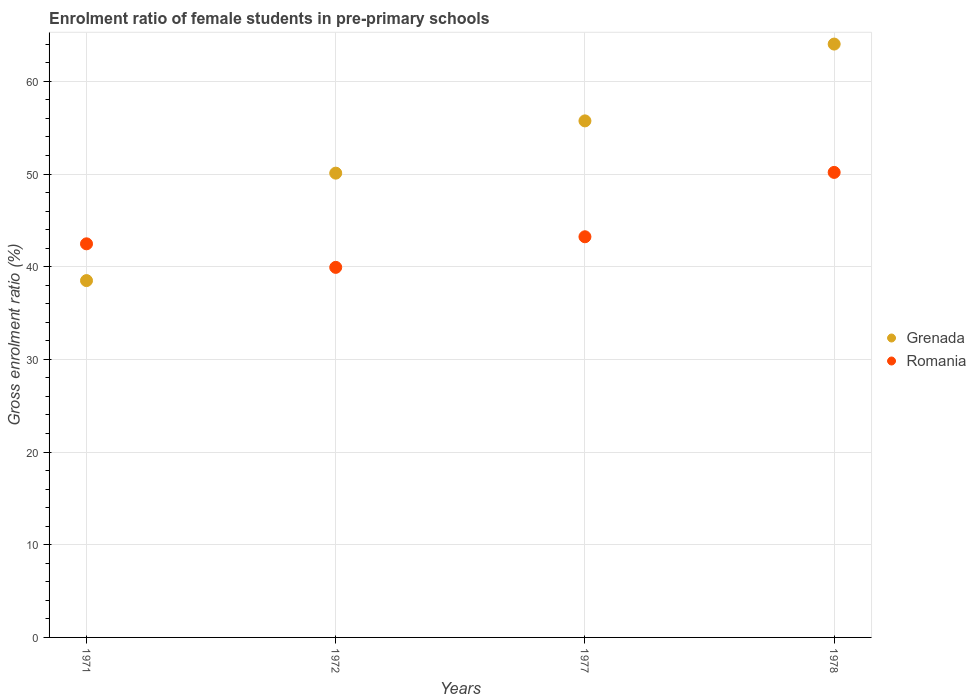Is the number of dotlines equal to the number of legend labels?
Provide a short and direct response. Yes. What is the enrolment ratio of female students in pre-primary schools in Romania in 1971?
Provide a succinct answer. 42.47. Across all years, what is the maximum enrolment ratio of female students in pre-primary schools in Romania?
Make the answer very short. 50.17. Across all years, what is the minimum enrolment ratio of female students in pre-primary schools in Romania?
Offer a very short reply. 39.93. In which year was the enrolment ratio of female students in pre-primary schools in Romania maximum?
Ensure brevity in your answer.  1978. What is the total enrolment ratio of female students in pre-primary schools in Grenada in the graph?
Offer a terse response. 208.35. What is the difference between the enrolment ratio of female students in pre-primary schools in Romania in 1972 and that in 1977?
Offer a very short reply. -3.3. What is the difference between the enrolment ratio of female students in pre-primary schools in Grenada in 1972 and the enrolment ratio of female students in pre-primary schools in Romania in 1977?
Make the answer very short. 6.86. What is the average enrolment ratio of female students in pre-primary schools in Romania per year?
Offer a terse response. 43.95. In the year 1978, what is the difference between the enrolment ratio of female students in pre-primary schools in Romania and enrolment ratio of female students in pre-primary schools in Grenada?
Provide a succinct answer. -13.85. What is the ratio of the enrolment ratio of female students in pre-primary schools in Romania in 1972 to that in 1977?
Ensure brevity in your answer.  0.92. Is the enrolment ratio of female students in pre-primary schools in Romania in 1971 less than that in 1972?
Provide a short and direct response. No. What is the difference between the highest and the second highest enrolment ratio of female students in pre-primary schools in Romania?
Give a very brief answer. 6.94. What is the difference between the highest and the lowest enrolment ratio of female students in pre-primary schools in Romania?
Provide a succinct answer. 10.25. How many years are there in the graph?
Offer a terse response. 4. Are the values on the major ticks of Y-axis written in scientific E-notation?
Offer a terse response. No. Does the graph contain grids?
Make the answer very short. Yes. How many legend labels are there?
Make the answer very short. 2. What is the title of the graph?
Offer a very short reply. Enrolment ratio of female students in pre-primary schools. Does "Colombia" appear as one of the legend labels in the graph?
Give a very brief answer. No. What is the Gross enrolment ratio (%) of Grenada in 1971?
Your response must be concise. 38.5. What is the Gross enrolment ratio (%) in Romania in 1971?
Give a very brief answer. 42.47. What is the Gross enrolment ratio (%) in Grenada in 1972?
Make the answer very short. 50.09. What is the Gross enrolment ratio (%) in Romania in 1972?
Give a very brief answer. 39.93. What is the Gross enrolment ratio (%) in Grenada in 1977?
Provide a short and direct response. 55.73. What is the Gross enrolment ratio (%) in Romania in 1977?
Provide a short and direct response. 43.23. What is the Gross enrolment ratio (%) of Grenada in 1978?
Your answer should be very brief. 64.02. What is the Gross enrolment ratio (%) of Romania in 1978?
Your response must be concise. 50.17. Across all years, what is the maximum Gross enrolment ratio (%) of Grenada?
Make the answer very short. 64.02. Across all years, what is the maximum Gross enrolment ratio (%) in Romania?
Offer a terse response. 50.17. Across all years, what is the minimum Gross enrolment ratio (%) in Grenada?
Provide a succinct answer. 38.5. Across all years, what is the minimum Gross enrolment ratio (%) in Romania?
Your answer should be compact. 39.93. What is the total Gross enrolment ratio (%) of Grenada in the graph?
Provide a succinct answer. 208.35. What is the total Gross enrolment ratio (%) in Romania in the graph?
Provide a short and direct response. 175.8. What is the difference between the Gross enrolment ratio (%) in Grenada in 1971 and that in 1972?
Provide a succinct answer. -11.59. What is the difference between the Gross enrolment ratio (%) of Romania in 1971 and that in 1972?
Offer a very short reply. 2.54. What is the difference between the Gross enrolment ratio (%) of Grenada in 1971 and that in 1977?
Provide a short and direct response. -17.23. What is the difference between the Gross enrolment ratio (%) in Romania in 1971 and that in 1977?
Provide a short and direct response. -0.76. What is the difference between the Gross enrolment ratio (%) in Grenada in 1971 and that in 1978?
Your answer should be very brief. -25.52. What is the difference between the Gross enrolment ratio (%) of Romania in 1971 and that in 1978?
Provide a short and direct response. -7.71. What is the difference between the Gross enrolment ratio (%) in Grenada in 1972 and that in 1977?
Your answer should be compact. -5.64. What is the difference between the Gross enrolment ratio (%) of Romania in 1972 and that in 1977?
Your answer should be compact. -3.3. What is the difference between the Gross enrolment ratio (%) in Grenada in 1972 and that in 1978?
Offer a very short reply. -13.93. What is the difference between the Gross enrolment ratio (%) of Romania in 1972 and that in 1978?
Your answer should be compact. -10.25. What is the difference between the Gross enrolment ratio (%) in Grenada in 1977 and that in 1978?
Provide a short and direct response. -8.29. What is the difference between the Gross enrolment ratio (%) in Romania in 1977 and that in 1978?
Make the answer very short. -6.94. What is the difference between the Gross enrolment ratio (%) of Grenada in 1971 and the Gross enrolment ratio (%) of Romania in 1972?
Offer a terse response. -1.43. What is the difference between the Gross enrolment ratio (%) in Grenada in 1971 and the Gross enrolment ratio (%) in Romania in 1977?
Your answer should be compact. -4.73. What is the difference between the Gross enrolment ratio (%) of Grenada in 1971 and the Gross enrolment ratio (%) of Romania in 1978?
Your response must be concise. -11.67. What is the difference between the Gross enrolment ratio (%) of Grenada in 1972 and the Gross enrolment ratio (%) of Romania in 1977?
Provide a short and direct response. 6.86. What is the difference between the Gross enrolment ratio (%) of Grenada in 1972 and the Gross enrolment ratio (%) of Romania in 1978?
Make the answer very short. -0.08. What is the difference between the Gross enrolment ratio (%) in Grenada in 1977 and the Gross enrolment ratio (%) in Romania in 1978?
Your answer should be compact. 5.56. What is the average Gross enrolment ratio (%) in Grenada per year?
Make the answer very short. 52.09. What is the average Gross enrolment ratio (%) of Romania per year?
Keep it short and to the point. 43.95. In the year 1971, what is the difference between the Gross enrolment ratio (%) in Grenada and Gross enrolment ratio (%) in Romania?
Provide a succinct answer. -3.97. In the year 1972, what is the difference between the Gross enrolment ratio (%) of Grenada and Gross enrolment ratio (%) of Romania?
Your answer should be compact. 10.17. In the year 1977, what is the difference between the Gross enrolment ratio (%) of Grenada and Gross enrolment ratio (%) of Romania?
Give a very brief answer. 12.5. In the year 1978, what is the difference between the Gross enrolment ratio (%) of Grenada and Gross enrolment ratio (%) of Romania?
Your answer should be compact. 13.85. What is the ratio of the Gross enrolment ratio (%) in Grenada in 1971 to that in 1972?
Your response must be concise. 0.77. What is the ratio of the Gross enrolment ratio (%) of Romania in 1971 to that in 1972?
Make the answer very short. 1.06. What is the ratio of the Gross enrolment ratio (%) of Grenada in 1971 to that in 1977?
Provide a succinct answer. 0.69. What is the ratio of the Gross enrolment ratio (%) in Romania in 1971 to that in 1977?
Provide a succinct answer. 0.98. What is the ratio of the Gross enrolment ratio (%) of Grenada in 1971 to that in 1978?
Offer a terse response. 0.6. What is the ratio of the Gross enrolment ratio (%) in Romania in 1971 to that in 1978?
Your response must be concise. 0.85. What is the ratio of the Gross enrolment ratio (%) in Grenada in 1972 to that in 1977?
Your answer should be compact. 0.9. What is the ratio of the Gross enrolment ratio (%) in Romania in 1972 to that in 1977?
Provide a short and direct response. 0.92. What is the ratio of the Gross enrolment ratio (%) of Grenada in 1972 to that in 1978?
Ensure brevity in your answer.  0.78. What is the ratio of the Gross enrolment ratio (%) of Romania in 1972 to that in 1978?
Offer a terse response. 0.8. What is the ratio of the Gross enrolment ratio (%) in Grenada in 1977 to that in 1978?
Your answer should be compact. 0.87. What is the ratio of the Gross enrolment ratio (%) of Romania in 1977 to that in 1978?
Offer a terse response. 0.86. What is the difference between the highest and the second highest Gross enrolment ratio (%) in Grenada?
Offer a terse response. 8.29. What is the difference between the highest and the second highest Gross enrolment ratio (%) of Romania?
Provide a succinct answer. 6.94. What is the difference between the highest and the lowest Gross enrolment ratio (%) in Grenada?
Offer a very short reply. 25.52. What is the difference between the highest and the lowest Gross enrolment ratio (%) of Romania?
Ensure brevity in your answer.  10.25. 